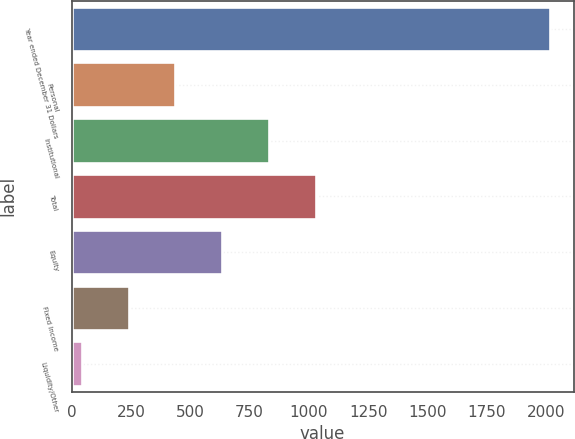<chart> <loc_0><loc_0><loc_500><loc_500><bar_chart><fcel>Year ended December 31 Dollars<fcel>Personal<fcel>Institutional<fcel>Total<fcel>Equity<fcel>Fixed Income<fcel>Liquidity/Other<nl><fcel>2015<fcel>436.6<fcel>831.2<fcel>1028.5<fcel>633.9<fcel>239.3<fcel>42<nl></chart> 